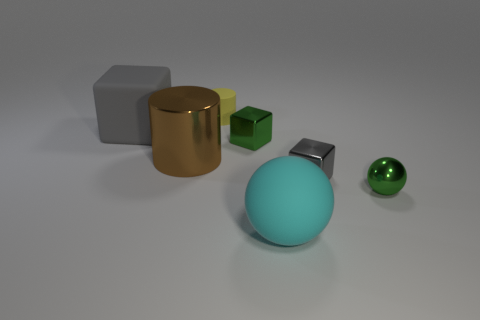Add 1 tiny gray shiny blocks. How many objects exist? 8 Subtract all balls. How many objects are left? 5 Subtract all cyan matte things. Subtract all tiny shiny blocks. How many objects are left? 4 Add 3 big matte objects. How many big matte objects are left? 5 Add 6 cyan objects. How many cyan objects exist? 7 Subtract 0 red spheres. How many objects are left? 7 